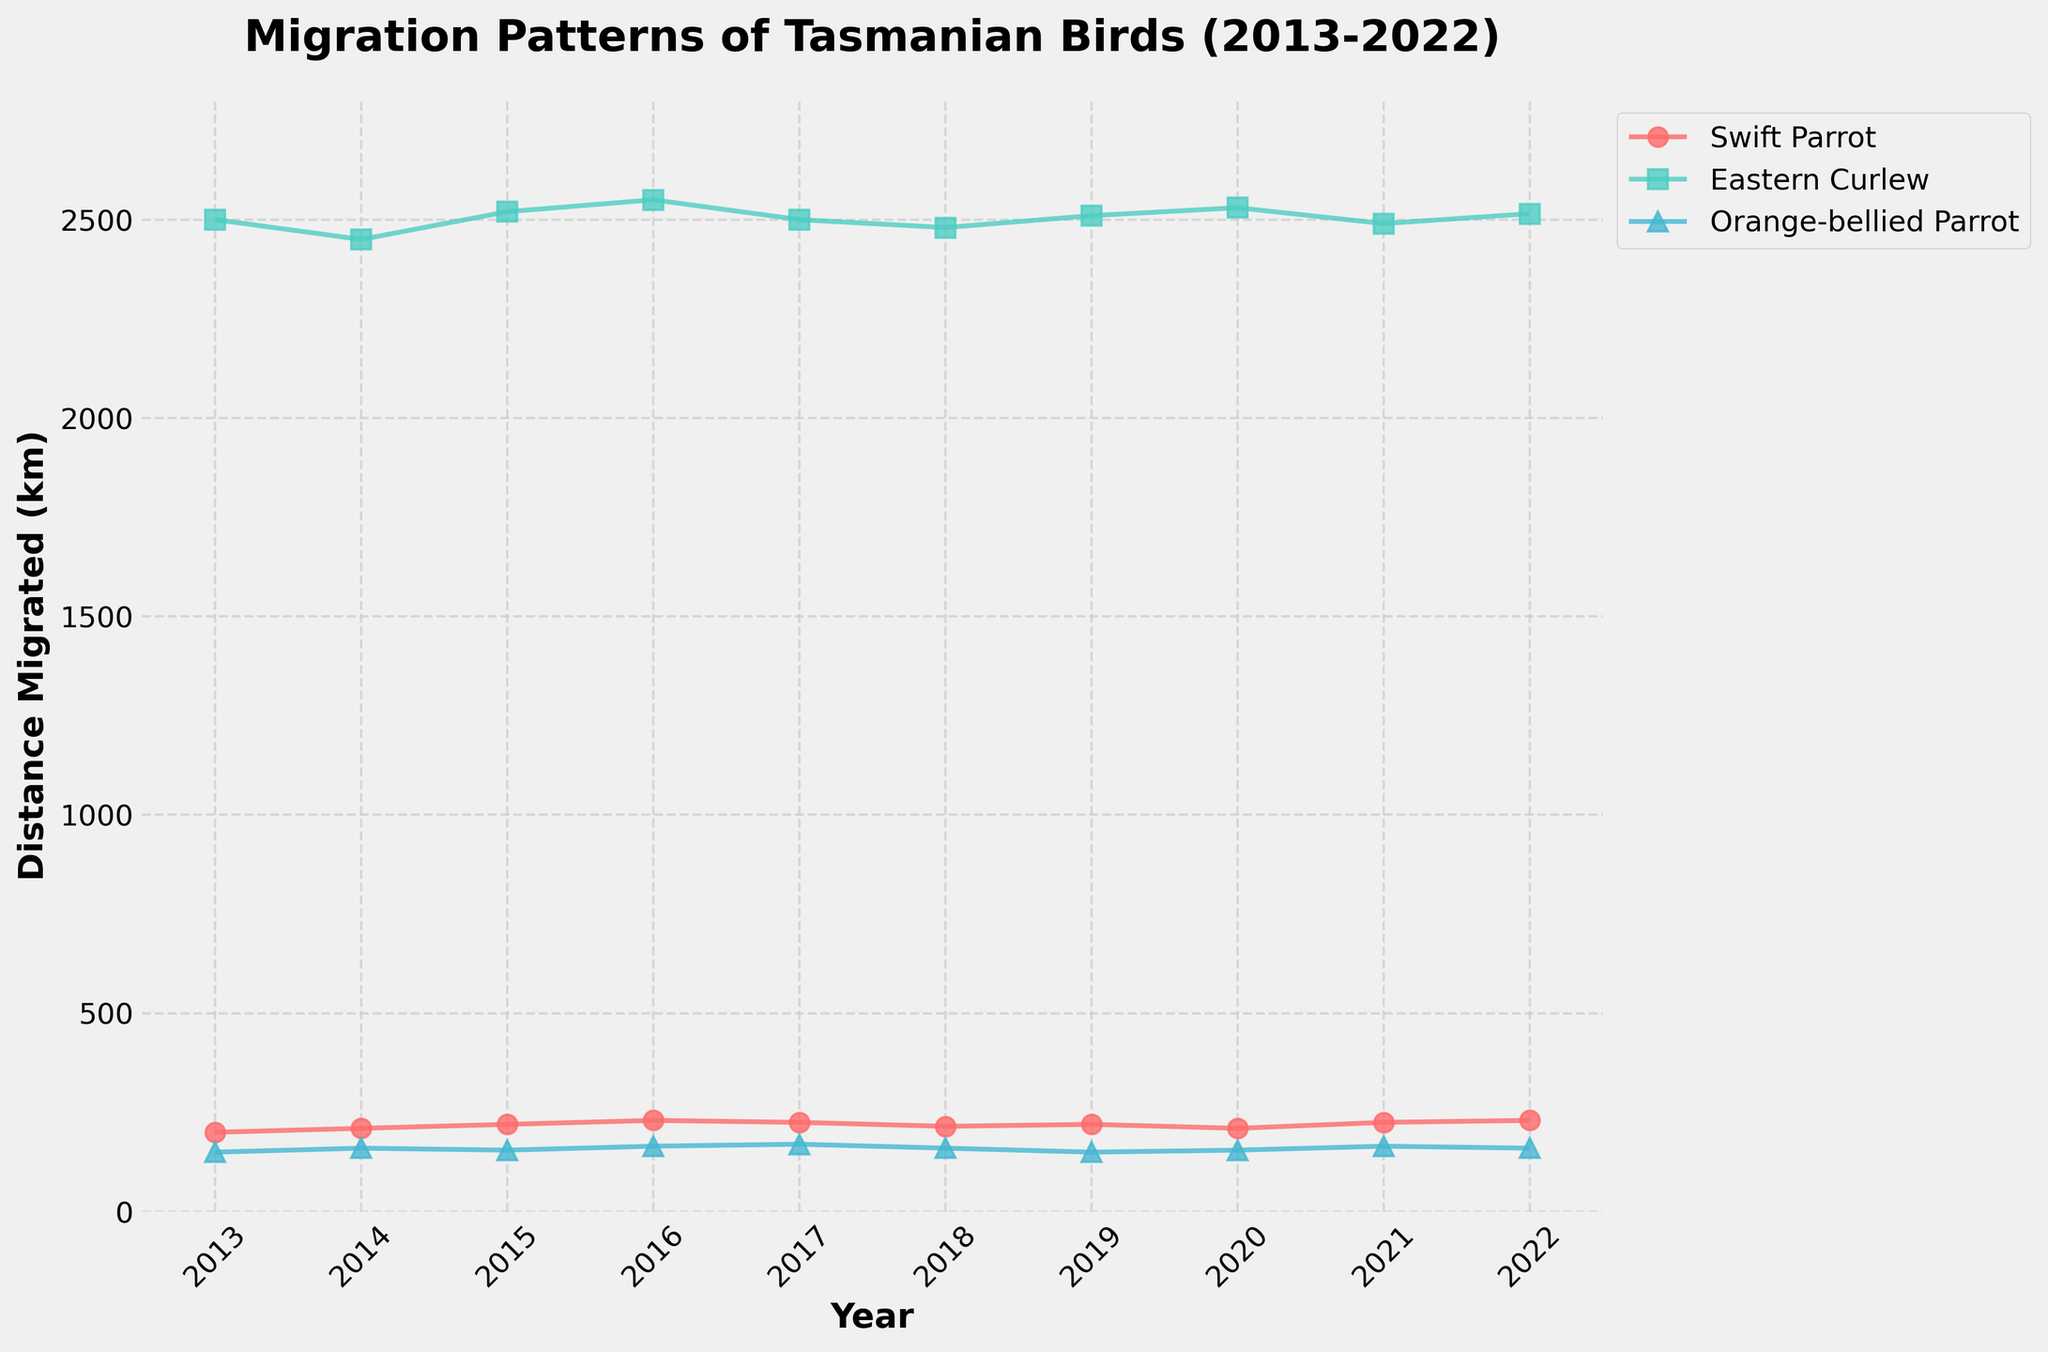What's the title of the figure? The title of the figure is the text displayed at the top of the plot. It provides an overview of what the figure represents. We can see that the title of the figure is "Migration Patterns of Tasmanian Birds (2013-2022)".
Answer: Migration Patterns of Tasmanian Birds (2013-2022) What is the y-axis label in the plot? The y-axis label is the descriptive text located along the vertical axis, which indicates what is being measured. In this plot, it is labeled as "Distance Migrated (km)".
Answer: Distance Migrated (km) How many species of birds are shown in the plot? The different species are identified by unique colors and markers. By looking at the legend of the plot, we can count three distinct bird species: Swift Parrot, Eastern Curlew, and Orange-bellied Parrot.
Answer: 3 Which bird species shows the greatest range in distance migrated over the years? To find the species with the greatest range in distance migrated, we need to look at the vertical lengths of migration lines for each species. Eastern Curlew has the highest variation, ranging from around 2450 km to 2550 km.
Answer: Eastern Curlew In which year did the Swift Parrot migrate the shortest distance? To identify the year when the Swift Parrot migrated the shortest distance, look at the lowest data point along the Swift Parrot line. This occurs in 2014, where the distance is approximately 210 km.
Answer: 2014 Approximately how much did the Orange-bellied Parrot’s maximum migration distance change from 2013 to 2022? We first identify the highest points for the Orange-bellied Parrot in 2013 (150 km) and 2022 (160 km). Then calculate the difference: 160 km - 150 km = 10 km.
Answer: 10 km Which year shows the closest migration distance for all three bird species? To find this, we need to look for the year where the distances migrated by all three species are visually the closest to one another. In 2013, the distances are approximately 200 km, 2500 km, and 150 km, which are visually close compared to other years.
Answer: 2013 Calculate the average distance migrated by the Swift Parrot over the entire period. First, sum the migration distances of the Swift Parrot from 2013 to 2022: 200 + 210 + 220 + 230 + 225 + 215 + 220 + 210 + 225 + 230. This totals to 2185 km. Divide by the number of years (10): 2185 / 10 = 218.5 km.
Answer: 218.5 km Compare the migration distances of the Eastern Curlew in 2016 and 2021. Which year had a higher migration distance and by how much? The migration distance in 2016 is 2550 km, and in 2021 it is 2490 km. The difference is 2550 - 2490 = 60 km, showing that 2016 had a higher migration distance by 60 km.
Answer: 2016 by 60 km Which species showed the most consistent migration distance over the years? Consistency means less variation. By observing the plot, the Orange-bellied Parrot shows less fluctuation in its migration distance across the years compared to the Swift Parrot and the Eastern Curlew.
Answer: Orange-bellied Parrot 